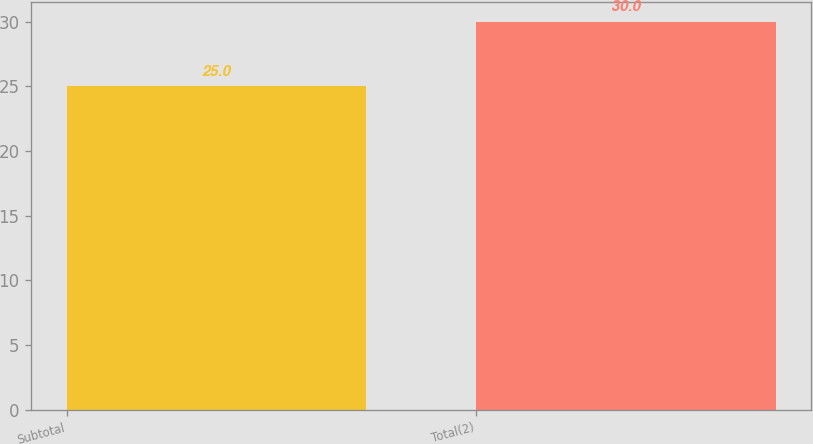Convert chart. <chart><loc_0><loc_0><loc_500><loc_500><bar_chart><fcel>Subtotal<fcel>Total(2)<nl><fcel>25<fcel>30<nl></chart> 